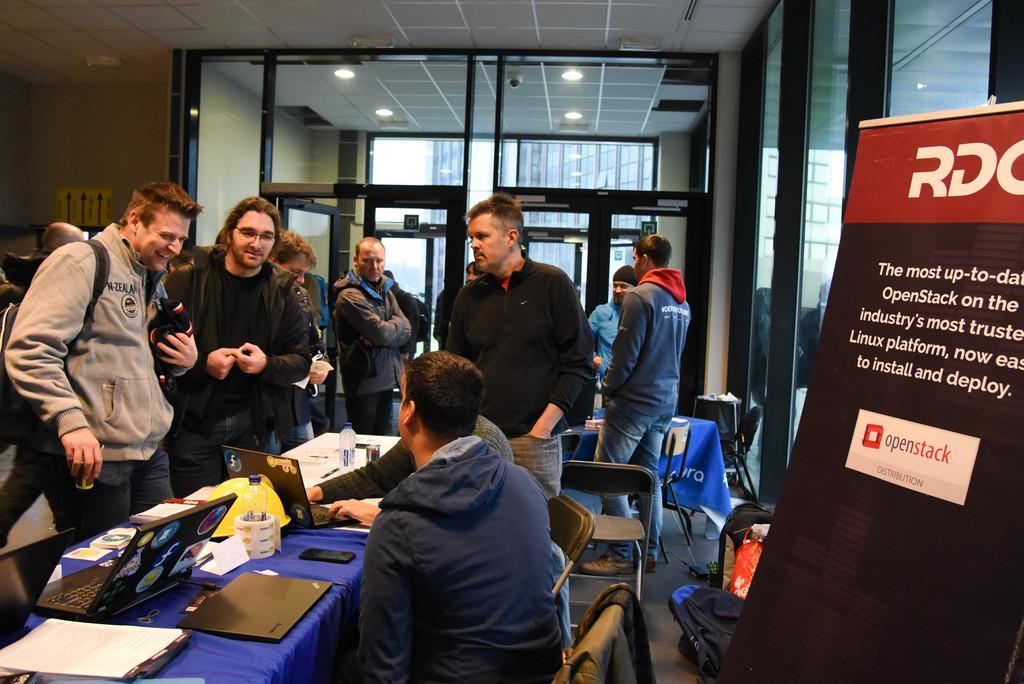In one or two sentences, can you explain what this image depicts? In front of the image there are two people sitting in chairs, in front of them on the table there are laptops, pens, cups and some other objects, in front of the table there are a few people standing and there are tables and chairs, on the tables there are some objects, behind them there is a banner, in the background of the image there are glass walls, at the top of the image there are lamps and there are some sign boards on the walls and there are some objects on the floor. 